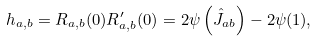Convert formula to latex. <formula><loc_0><loc_0><loc_500><loc_500>h _ { a , b } = R _ { a , b } ( 0 ) R ^ { \prime } _ { a , b } ( 0 ) = 2 \psi \left ( \hat { J } _ { a b } \right ) - 2 \psi ( 1 ) ,</formula> 